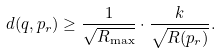<formula> <loc_0><loc_0><loc_500><loc_500>d ( q , p _ { r } ) \geq \frac { 1 } { \sqrt { R _ { \max } } } \cdot \frac { k } { \sqrt { R ( p _ { r } ) } } .</formula> 